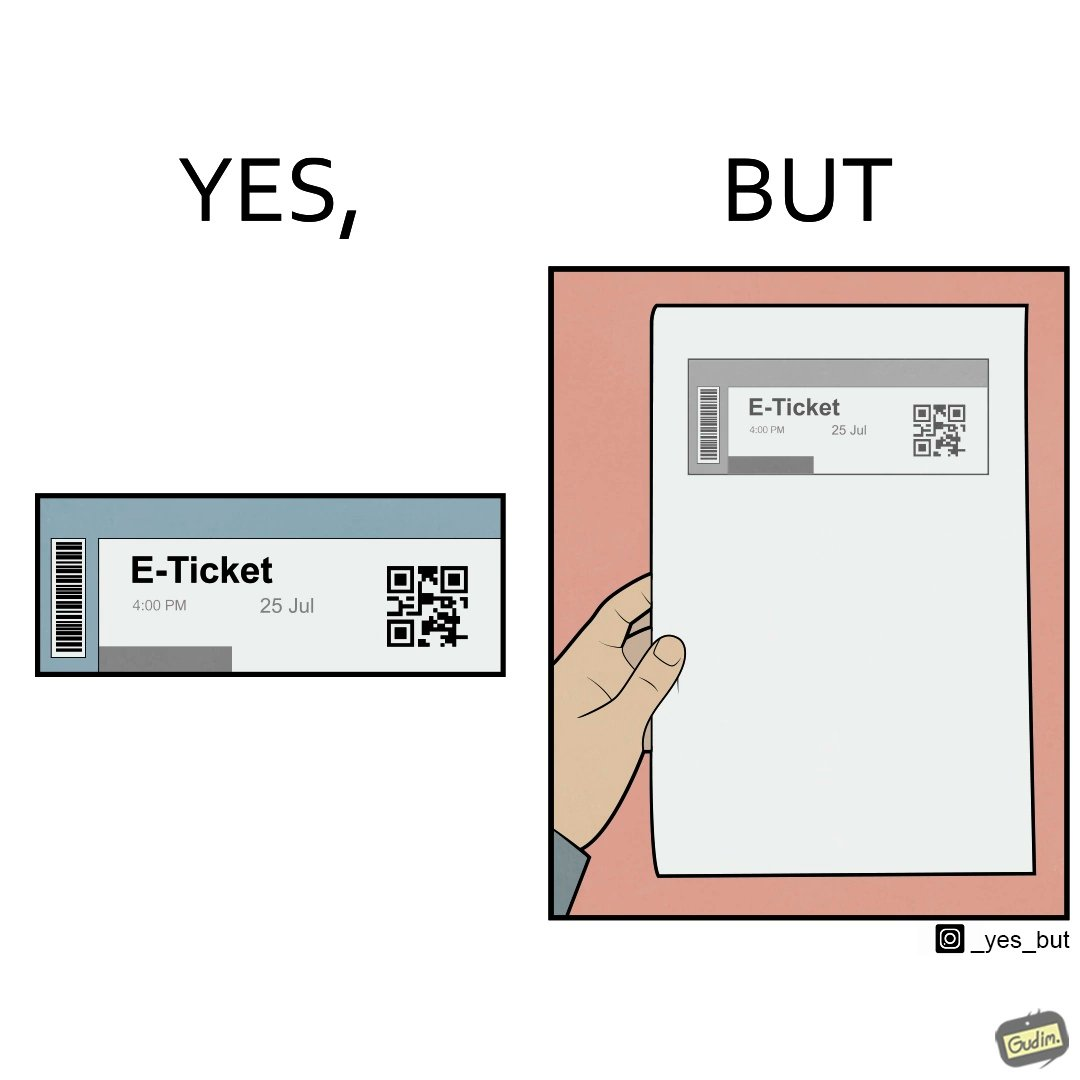Does this image contain satire or humor? Yes, this image is satirical. 